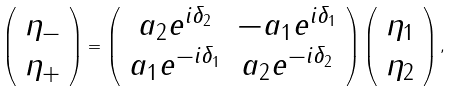Convert formula to latex. <formula><loc_0><loc_0><loc_500><loc_500>\left ( \begin{array} { c } \eta _ { - } \\ \eta _ { + } \end{array} \right ) = \left ( \begin{array} { c c } a _ { 2 } e ^ { i \delta _ { 2 } } & - a _ { 1 } e ^ { i \delta _ { 1 } } \\ a _ { 1 } e ^ { - i \delta _ { 1 } } & a _ { 2 } e ^ { - i \delta _ { 2 } } \end{array} \right ) \left ( \begin{array} { c } \eta _ { 1 } \\ \eta _ { 2 } \end{array} \right ) ,</formula> 